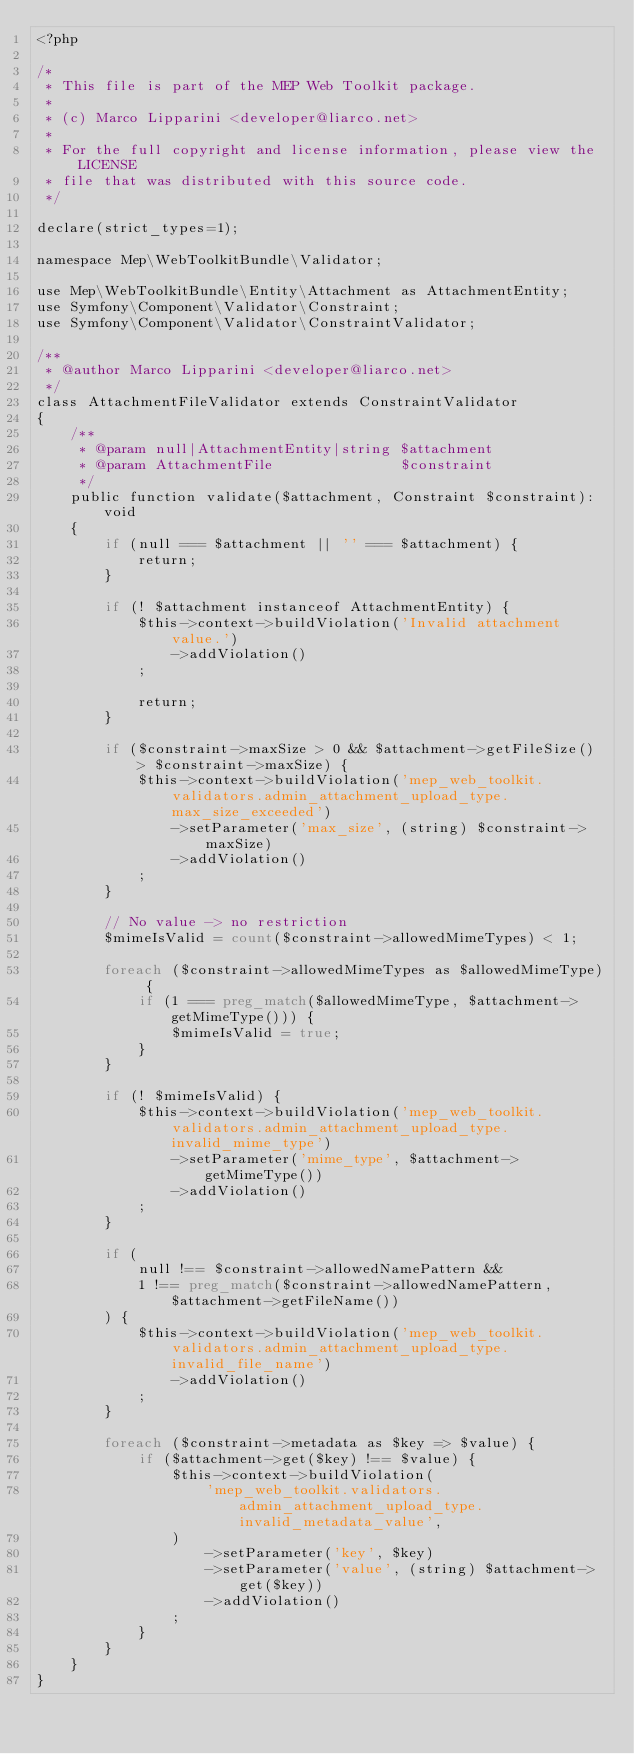<code> <loc_0><loc_0><loc_500><loc_500><_PHP_><?php

/*
 * This file is part of the MEP Web Toolkit package.
 *
 * (c) Marco Lipparini <developer@liarco.net>
 *
 * For the full copyright and license information, please view the LICENSE
 * file that was distributed with this source code.
 */

declare(strict_types=1);

namespace Mep\WebToolkitBundle\Validator;

use Mep\WebToolkitBundle\Entity\Attachment as AttachmentEntity;
use Symfony\Component\Validator\Constraint;
use Symfony\Component\Validator\ConstraintValidator;

/**
 * @author Marco Lipparini <developer@liarco.net>
 */
class AttachmentFileValidator extends ConstraintValidator
{
    /**
     * @param null|AttachmentEntity|string $attachment
     * @param AttachmentFile               $constraint
     */
    public function validate($attachment, Constraint $constraint): void
    {
        if (null === $attachment || '' === $attachment) {
            return;
        }

        if (! $attachment instanceof AttachmentEntity) {
            $this->context->buildViolation('Invalid attachment value.')
                ->addViolation()
            ;

            return;
        }

        if ($constraint->maxSize > 0 && $attachment->getFileSize() > $constraint->maxSize) {
            $this->context->buildViolation('mep_web_toolkit.validators.admin_attachment_upload_type.max_size_exceeded')
                ->setParameter('max_size', (string) $constraint->maxSize)
                ->addViolation()
            ;
        }

        // No value -> no restriction
        $mimeIsValid = count($constraint->allowedMimeTypes) < 1;

        foreach ($constraint->allowedMimeTypes as $allowedMimeType) {
            if (1 === preg_match($allowedMimeType, $attachment->getMimeType())) {
                $mimeIsValid = true;
            }
        }

        if (! $mimeIsValid) {
            $this->context->buildViolation('mep_web_toolkit.validators.admin_attachment_upload_type.invalid_mime_type')
                ->setParameter('mime_type', $attachment->getMimeType())
                ->addViolation()
            ;
        }

        if (
            null !== $constraint->allowedNamePattern &&
            1 !== preg_match($constraint->allowedNamePattern, $attachment->getFileName())
        ) {
            $this->context->buildViolation('mep_web_toolkit.validators.admin_attachment_upload_type.invalid_file_name')
                ->addViolation()
            ;
        }

        foreach ($constraint->metadata as $key => $value) {
            if ($attachment->get($key) !== $value) {
                $this->context->buildViolation(
                    'mep_web_toolkit.validators.admin_attachment_upload_type.invalid_metadata_value',
                )
                    ->setParameter('key', $key)
                    ->setParameter('value', (string) $attachment->get($key))
                    ->addViolation()
                ;
            }
        }
    }
}
</code> 